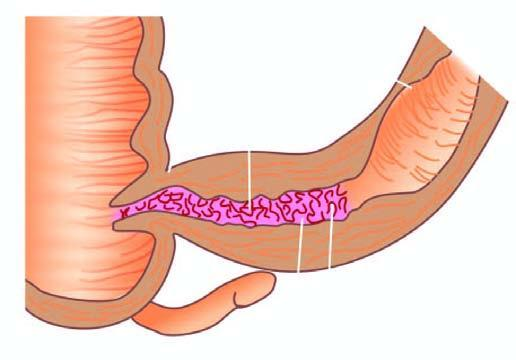what does external surface show?
Answer the question using a single word or phrase. Increased mesenteric fat 